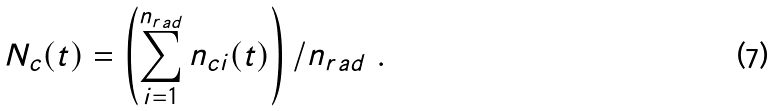<formula> <loc_0><loc_0><loc_500><loc_500>N _ { c } ( t ) = \left ( \sum _ { i = 1 } ^ { n _ { r a d } } n _ { c i } ( t ) \right ) / n _ { r a d } \ .</formula> 